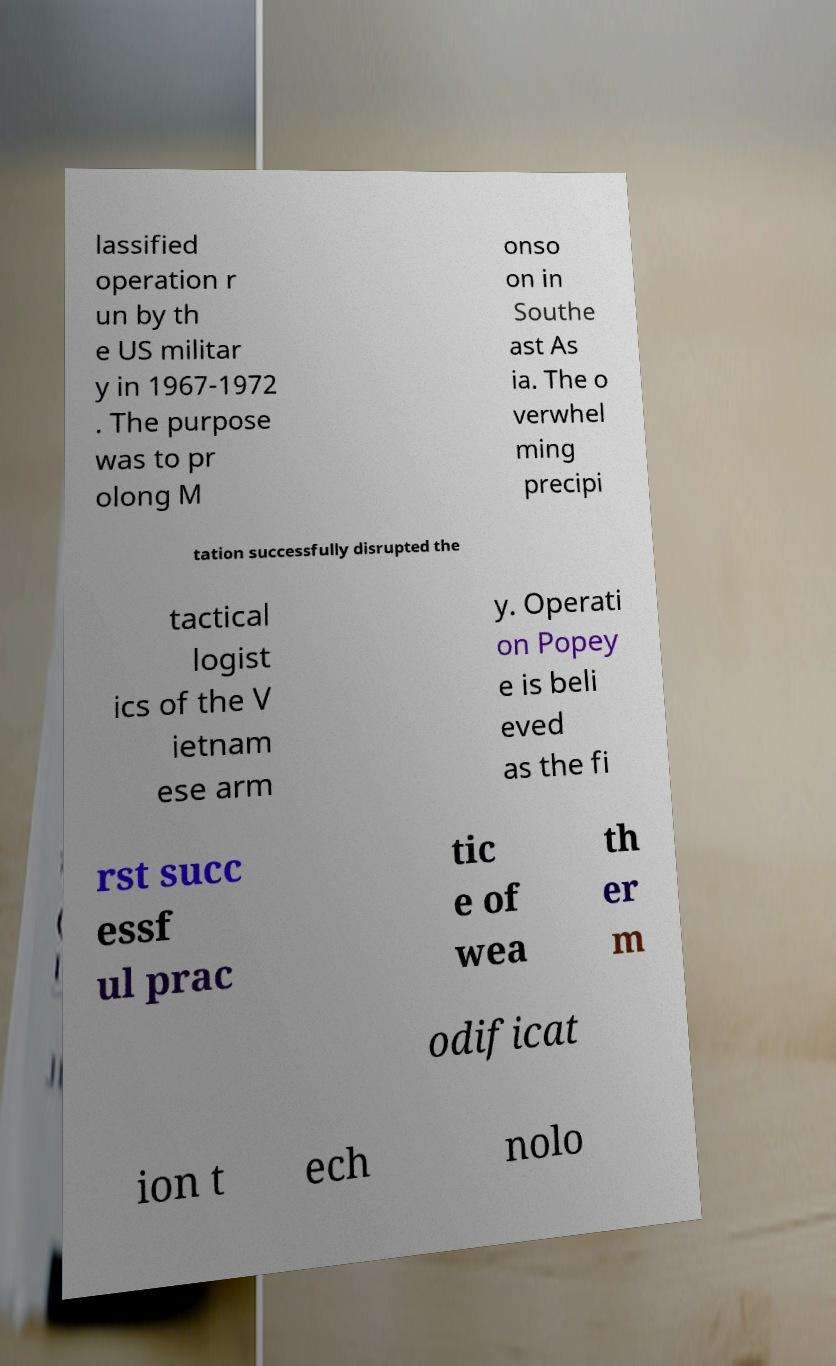For documentation purposes, I need the text within this image transcribed. Could you provide that? lassified operation r un by th e US militar y in 1967-1972 . The purpose was to pr olong M onso on in Southe ast As ia. The o verwhel ming precipi tation successfully disrupted the tactical logist ics of the V ietnam ese arm y. Operati on Popey e is beli eved as the fi rst succ essf ul prac tic e of wea th er m odificat ion t ech nolo 